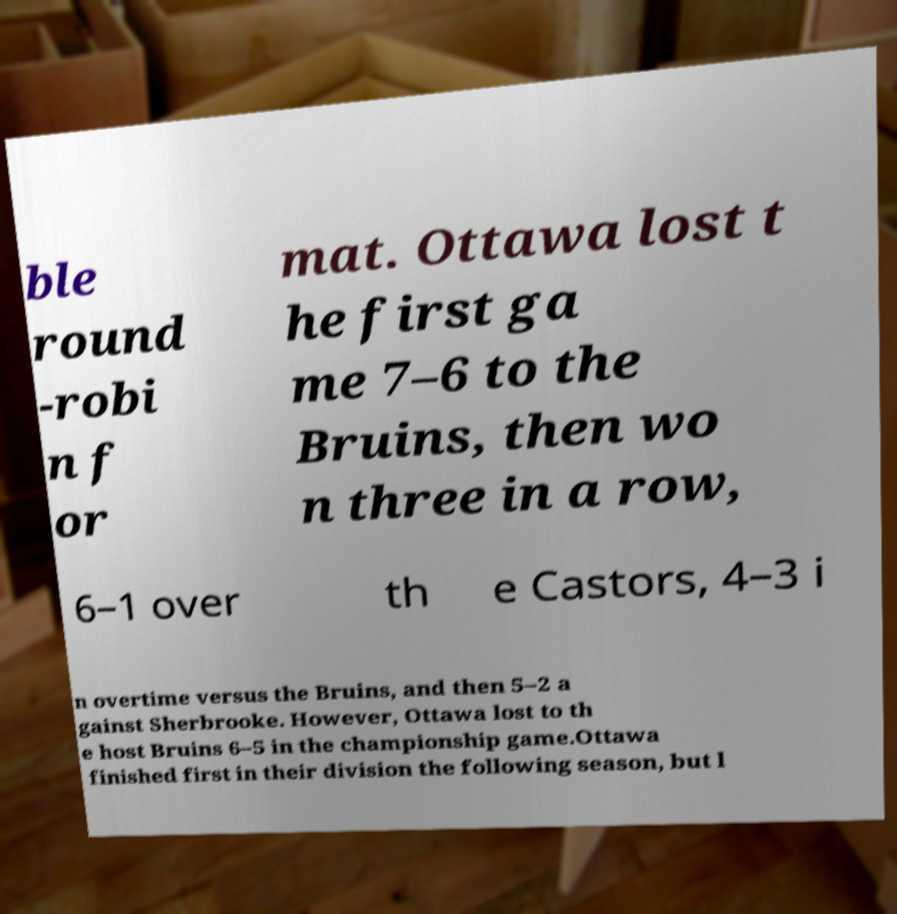Can you accurately transcribe the text from the provided image for me? ble round -robi n f or mat. Ottawa lost t he first ga me 7–6 to the Bruins, then wo n three in a row, 6–1 over th e Castors, 4–3 i n overtime versus the Bruins, and then 5–2 a gainst Sherbrooke. However, Ottawa lost to th e host Bruins 6–5 in the championship game.Ottawa finished first in their division the following season, but l 